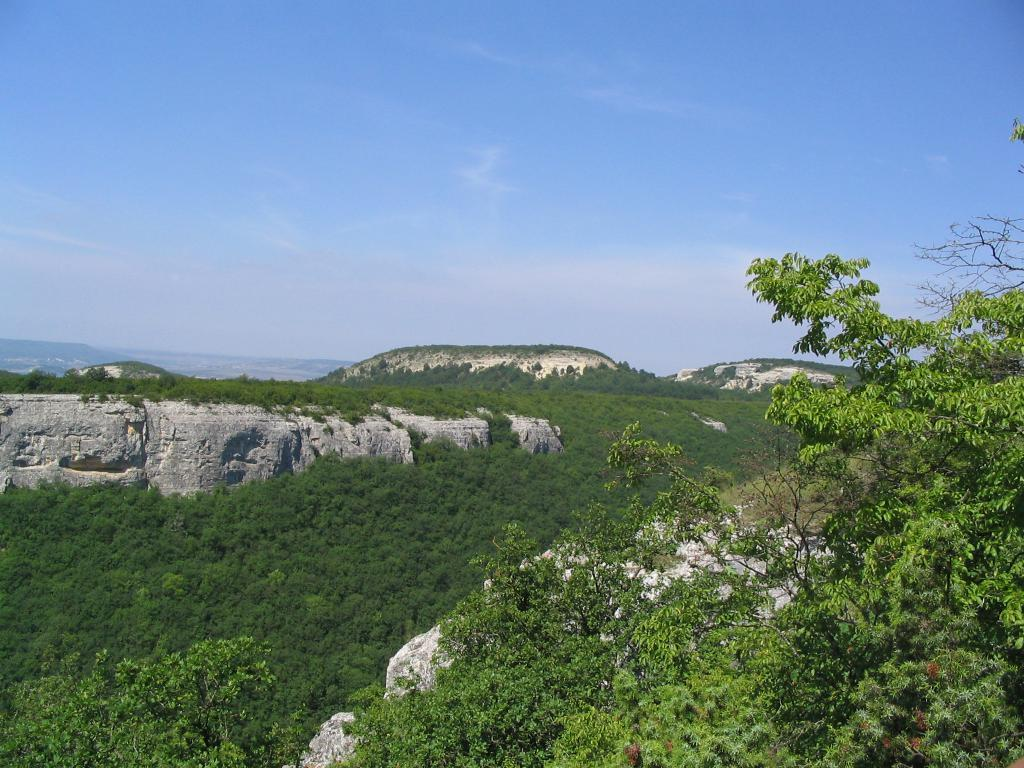What type of landscape is depicted in the image? The image features hills. What other natural elements can be seen in the image? There are trees in the image. Where is the sister standing in the image? There is no sister present in the image. What type of wire is used to support the trees in the image? There is no wire visible in the image; the trees are standing on their own. 